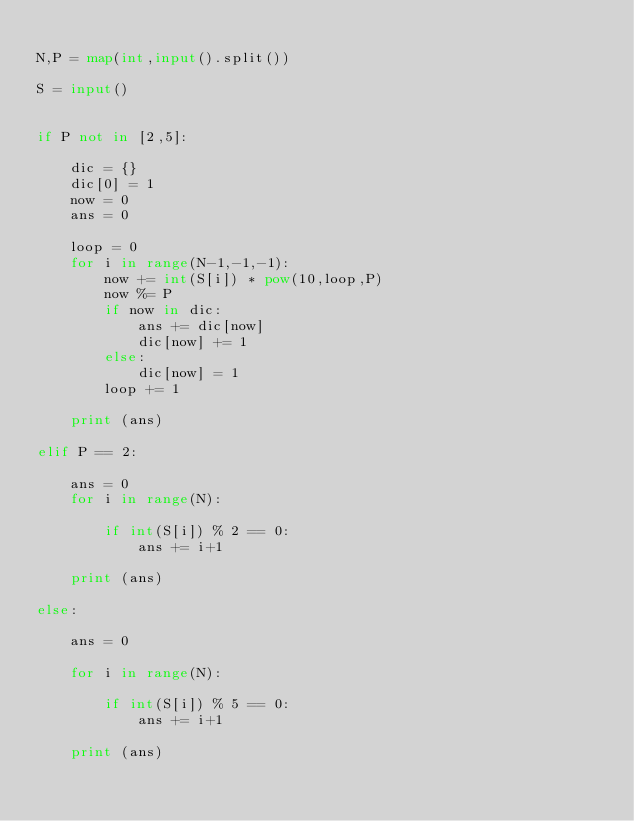Convert code to text. <code><loc_0><loc_0><loc_500><loc_500><_Python_>
N,P = map(int,input().split())

S = input()


if P not in [2,5]:

    dic = {}
    dic[0] = 1
    now = 0
    ans = 0

    loop = 0
    for i in range(N-1,-1,-1):
        now += int(S[i]) * pow(10,loop,P)
        now %= P
        if now in dic:
            ans += dic[now]
            dic[now] += 1
        else:
            dic[now] = 1
        loop += 1

    print (ans)

elif P == 2:

    ans = 0
    for i in range(N):

        if int(S[i]) % 2 == 0:
            ans += i+1

    print (ans)

else:

    ans = 0

    for i in range(N):

        if int(S[i]) % 5 == 0:
            ans += i+1

    print (ans)
    
</code> 